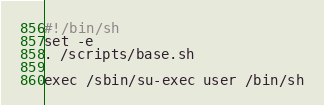<code> <loc_0><loc_0><loc_500><loc_500><_Bash_>#!/bin/sh
set -e
. /scripts/base.sh

exec /sbin/su-exec user /bin/sh
</code> 